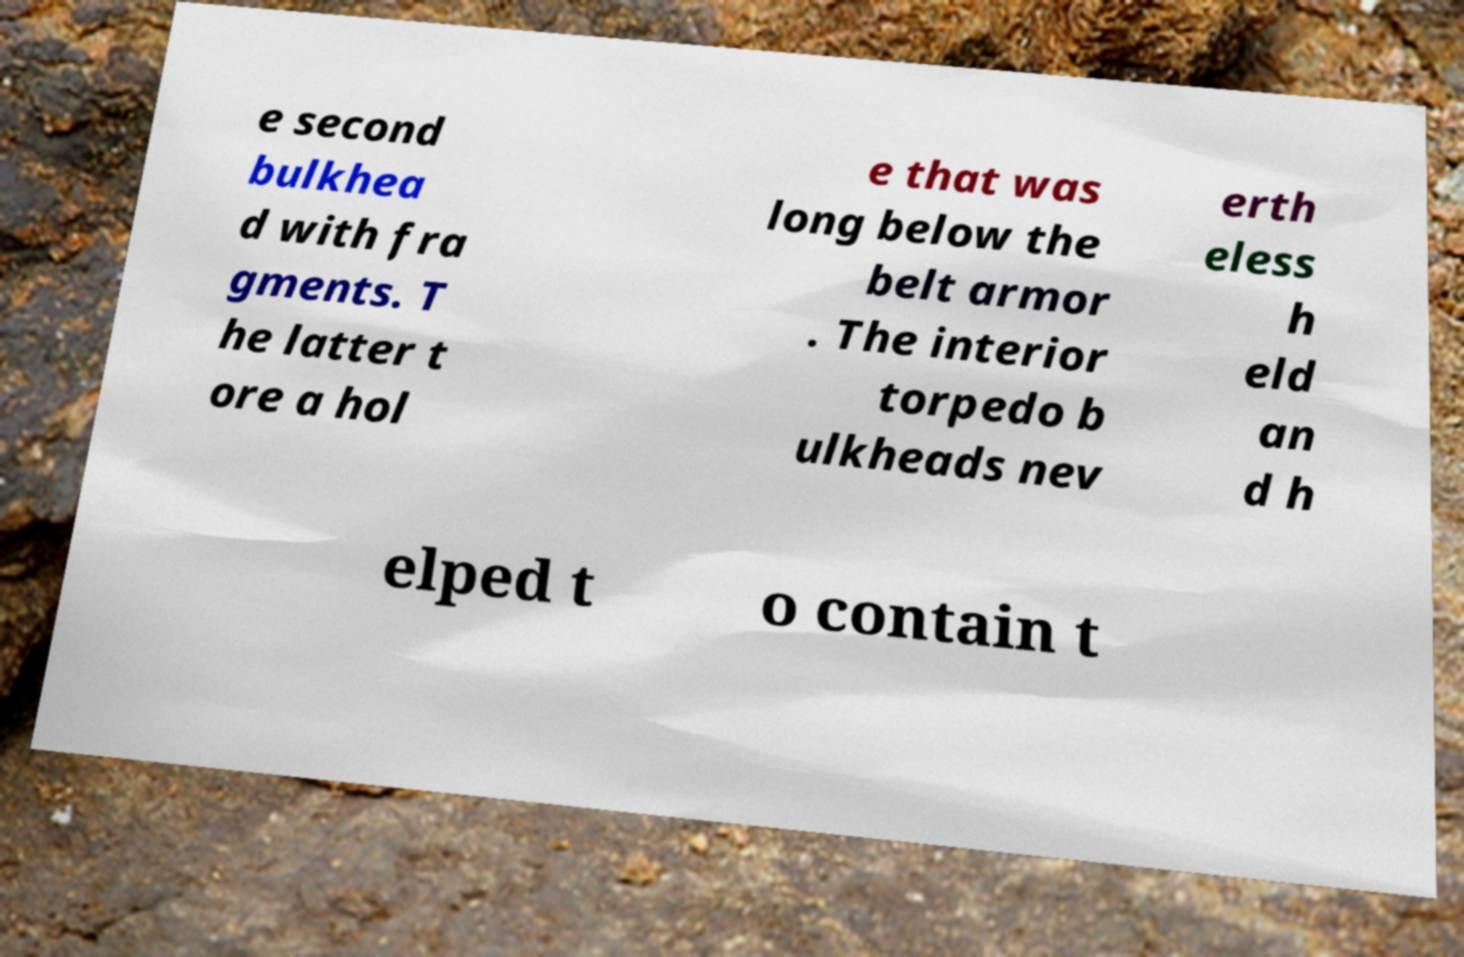For documentation purposes, I need the text within this image transcribed. Could you provide that? e second bulkhea d with fra gments. T he latter t ore a hol e that was long below the belt armor . The interior torpedo b ulkheads nev erth eless h eld an d h elped t o contain t 